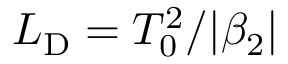Convert formula to latex. <formula><loc_0><loc_0><loc_500><loc_500>L _ { D } = T _ { 0 } ^ { 2 } / | \beta _ { 2 } |</formula> 